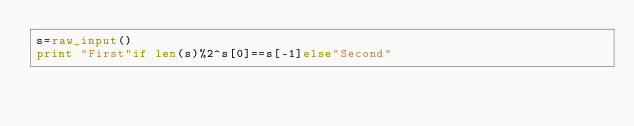Convert code to text. <code><loc_0><loc_0><loc_500><loc_500><_Python_>s=raw_input()
print "First"if len(s)%2^s[0]==s[-1]else"Second"</code> 